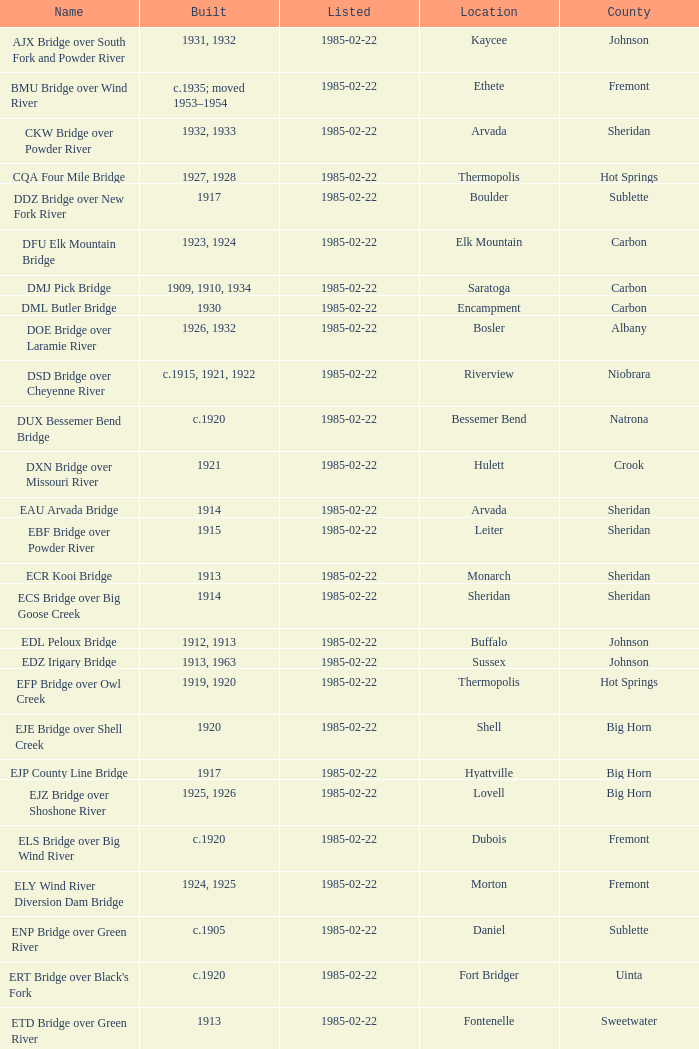What is the administrative division of the bridge in boulder? Sublette. 